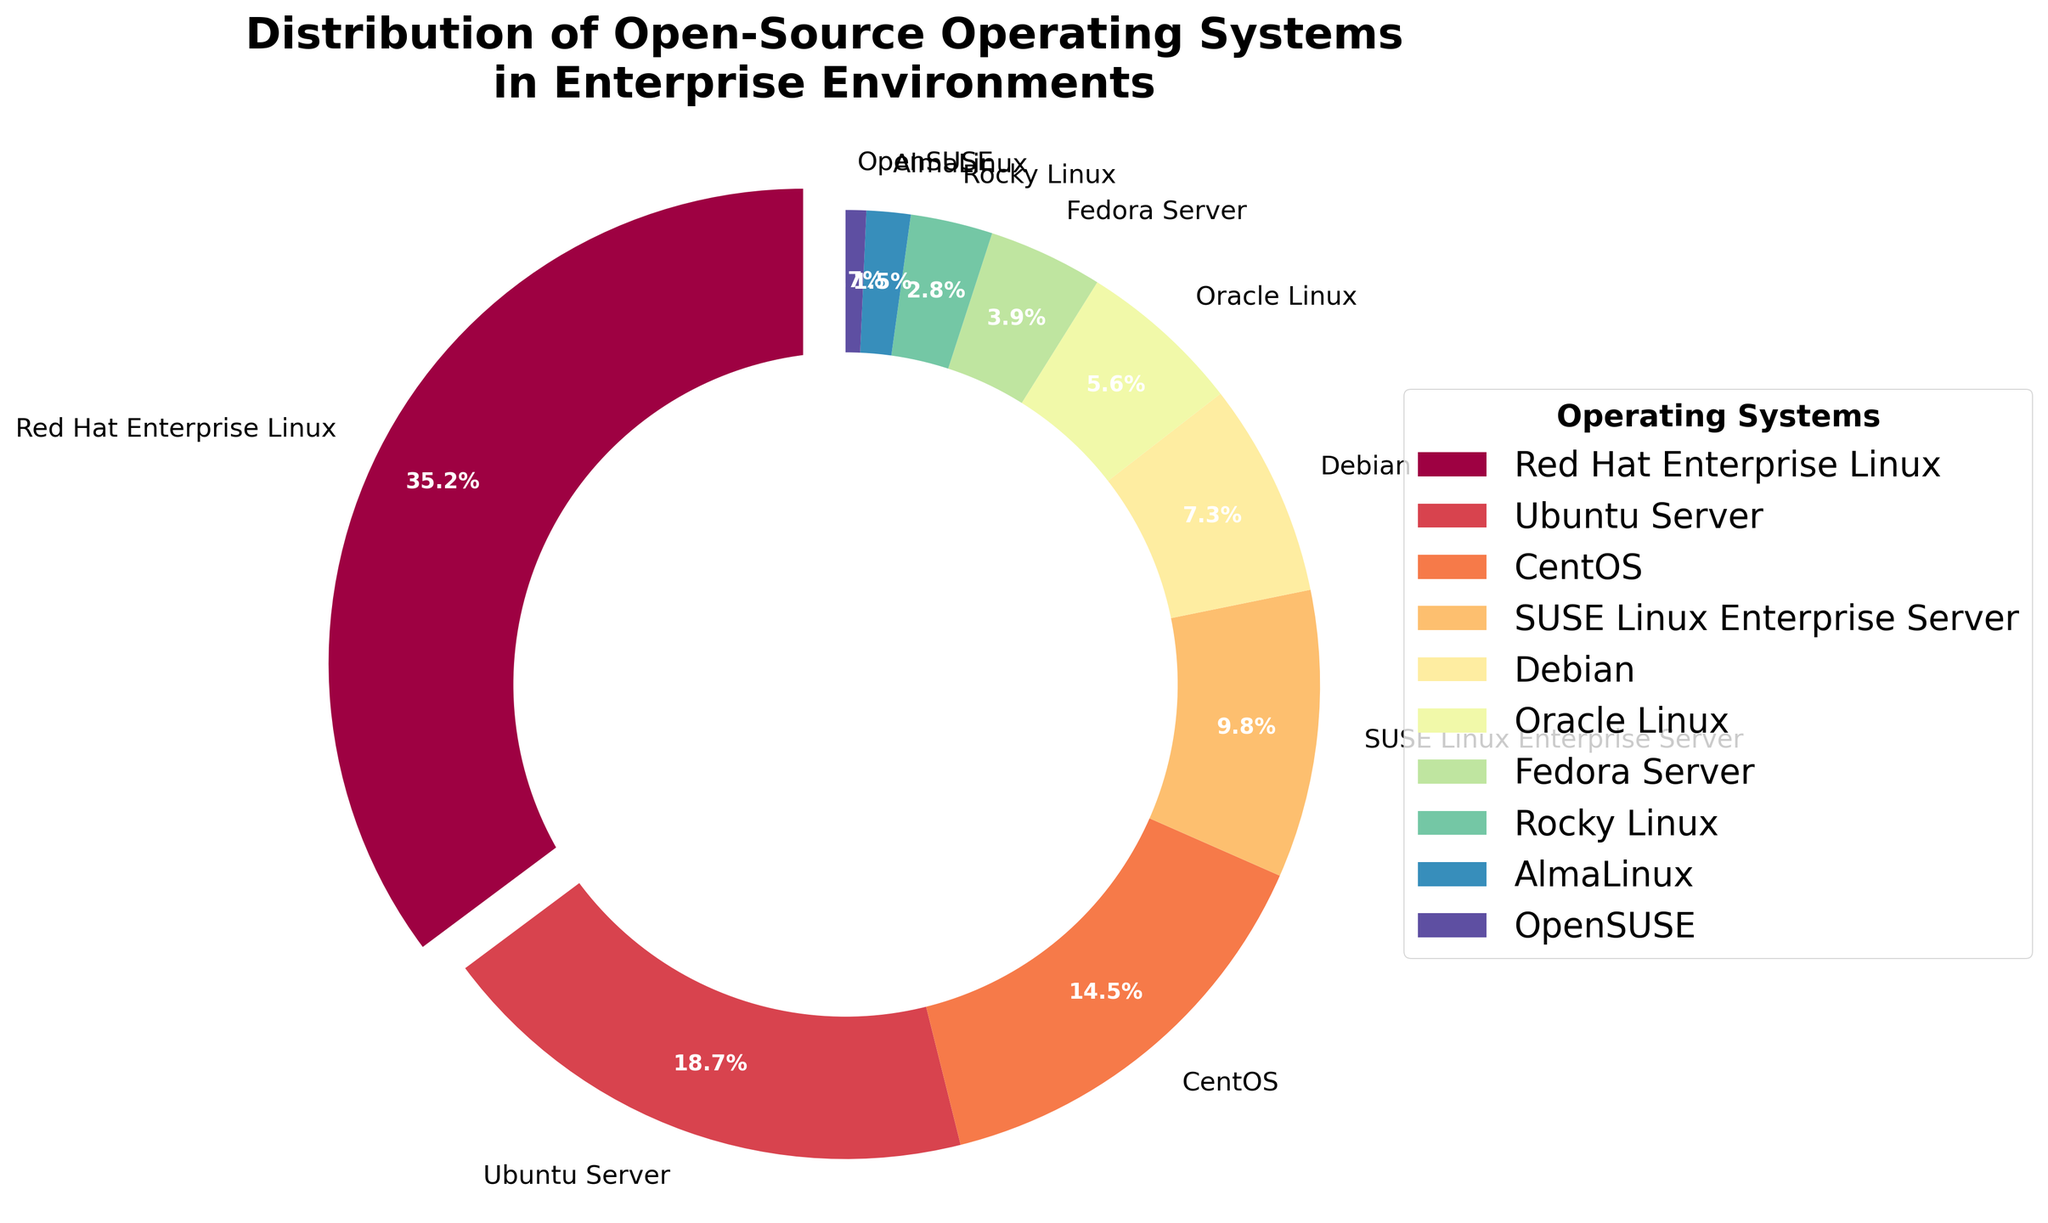Which open-source operating system has the largest share in enterprise environments? The figure shows the distribution of open-source operating systems used in enterprise environments with corresponding percentages. The largest share is represented by Red Hat Enterprise Linux at 35.2%.
Answer: Red Hat Enterprise Linux What is the combined percentage of Ubuntu Server and CentOS? The figure indicates the percentage for Ubuntu Server as 18.7% and CentOS as 14.5%. Adding these together gives 18.7 + 14.5.
Answer: 33.2% Which operating system has a smaller share, Fedora Server or SUSE Linux Enterprise Server? By comparing the percentages in the figure, Fedora Server has 3.9% and SUSE Linux Enterprise Server has 9.8%. 3.9% is smaller than 9.8%.
Answer: Fedora Server How much larger is the share of Red Hat Enterprise Linux compared to Oracle Linux? The figure shows Red Hat Enterprise Linux at 35.2% and Oracle Linux at 5.6%. Subtracting these values gives 35.2 - 5.6.
Answer: 29.6% Which operating systems have less than 5% share? By checking the figure for operating systems with percentages less than 5%: Oracle Linux (5.6%), Fedora Server (3.9%), Rocky Linux (2.8%), AlmaLinux (1.5%), and OpenSUSE (0.7%) are the ones.
Answer: Fedora Server, Rocky Linux, AlmaLinux, OpenSUSE What is the total percentage of all operating systems other than Red Hat Enterprise Linux? Subtract the percentage of Red Hat Enterprise Linux (35.2%) from 100% to find the total for the other operating systems. 100 - 35.2.
Answer: 64.8% Does Ubuntu Server have a higher percentage than SUSE Linux Enterprise Server and Debian combined? The figure shows Ubuntu Server at 18.7%, SUSE Linux Enterprise Server at 9.8%, and Debian at 7.3%. Adding SUSE Linux Enterprise Server and Debian gives 9.8 + 7.3 = 17.1%, which is less than 18.7%.
Answer: Yes What is the share difference between the second most and the third most used operating systems? The second most used is Ubuntu Server at 18.7% and the third most used is CentOS at 14.5%. Subtracting these gives 18.7 - 14.5.
Answer: 4.2% Which operating system has about 10% share and what color represents it? The figure shows that SUSE Linux Enterprise Server has a share of 9.8%, which is approximately 10%. The color representing this share can be inferred from the figurative legend provided.
Answer: SUSE Linux Enterprise Server, color varies (as per the figure) How many operating systems have a share greater than 10%? By examining the figure, three operating systems have a share greater than 10%: Red Hat Enterprise Linux (35.2%), Ubuntu Server (18.7%), and CentOS (14.5%).
Answer: Three 